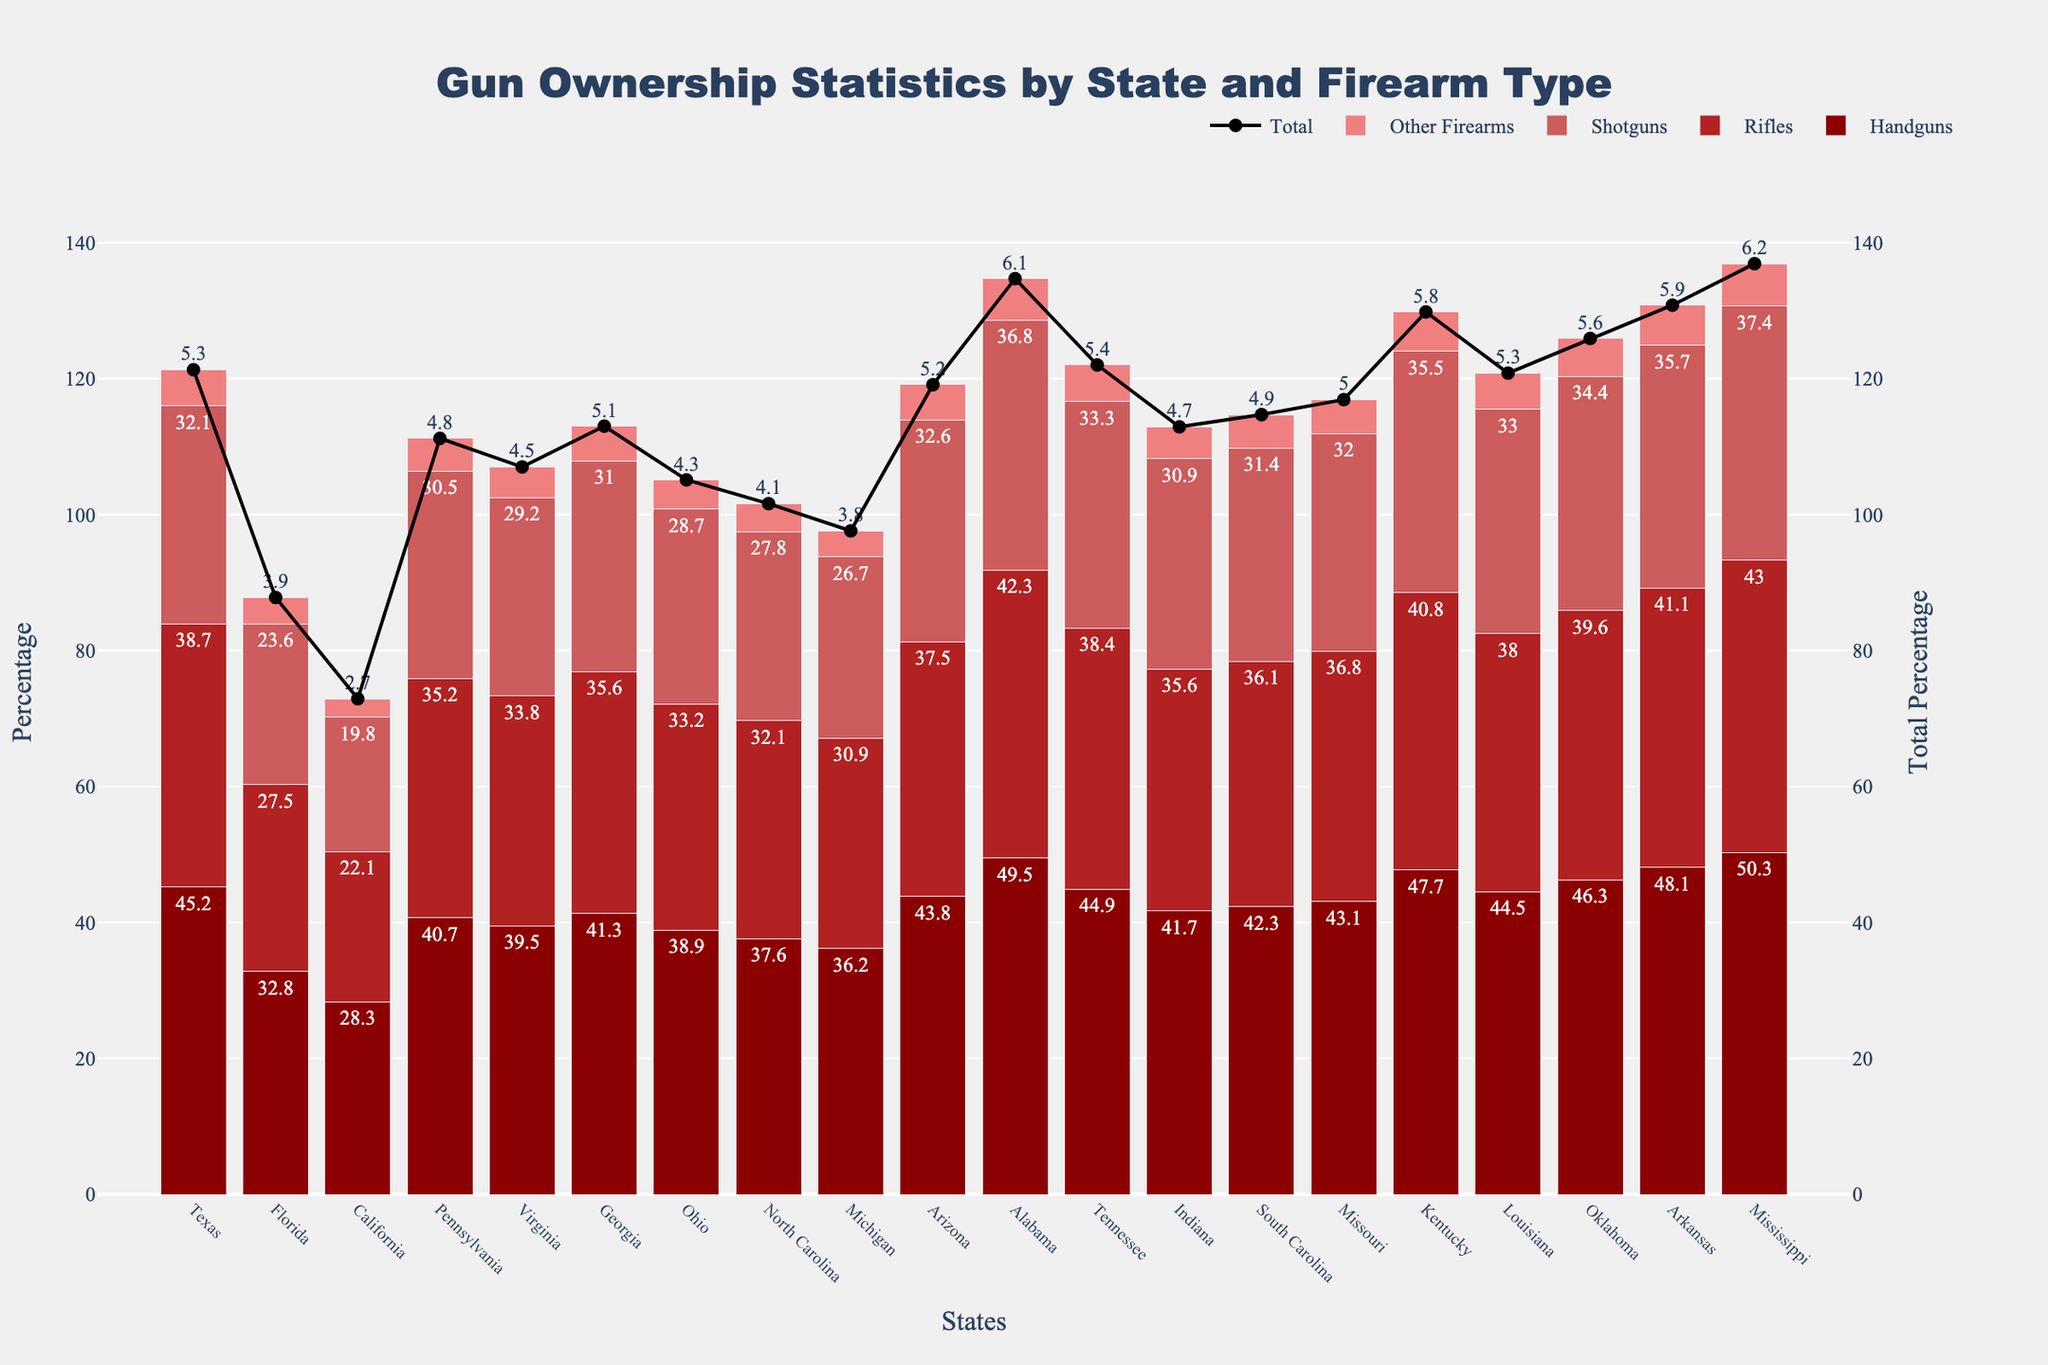Which state has the highest percentage of handguns? From the figure, observe the height of the bars representing handguns across all states. The tallest bar for handguns is in Mississippi.
Answer: Mississippi What is the total percentage of firearms owned in Texas? Sum the percentages of all firearm types (Handguns, Rifles, Shotguns, Other Firearms) in Texas: 45.2 + 38.7 + 32.1 + 5.3.
Answer: 121.3 Which state shows the lowest percentage for "Other Firearms"? Observe the bars for the "Other Firearms" category and identify the shortest one, which is in California.
Answer: California How does the percentage of shotguns in Arizona compare to that in Alabama? Observe the height of the bars for shotguns in both Arizona and Alabama. Arizona's shotgun percentage is 32.6, while Alabama's is 36.8. Arizona's percentage is lower than Alabama's.
Answer: Lower What is the difference in total firearm ownership between Alabama and California? Calculate the sum of all firearm types for both states: Alabama (49.5 + 42.3 + 36.8 + 6.1) = 134.7; California (28.3 + 22.1 + 19.8 + 2.7) = 72.9. The difference is 134.7 - 72.9.
Answer: 61.8 Compare the handgun ownership percentage of Georgia and Ohio. Which state has a higher percentage? Look at the bars for handguns in both states. Georgia has 41.3%, whereas Ohio has 38.9%. Georgia has a higher percentage.
Answer: Georgia Determine the ratio of rifle ownership in Kentucky to that in Indiana. Divide the percentages of rifle ownership in Kentucky by that in Indiana: (40.8 / 35.6).
Answer: 1.15 What is the average percentage of shotguns owned across all states? Sum the shotgun percentages for all states and divide by the number of states: (32.1 + 23.6 + 19.8 + 30.5 + 29.2 + 31.0 + 28.7 + 27.8 + 26.7 + 32.6 + 36.8 + 33.3 + 30.9 + 31.4 + 32.0 + 35.5 + 33.0 + 34.4 + 35.7 + 37.4) / 20.
Answer: 30.95 In terms of total firearm ownership, which state ranks second highest after Alabama? Notice the lines representing the total percentage. After Alabama, the second highest line is for Mississippi.
Answer: Mississippi Which firearm type is most evenly distributed across all states? Compare the variations in the height of bars for all firearm types. The "Other Firearms" category shows the least variation and is most evenly distributed.
Answer: Other Firearms 